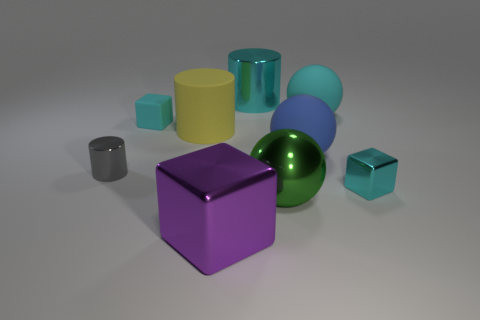What material is the big yellow object that is the same shape as the gray object?
Provide a succinct answer. Rubber. There is a cube that is behind the tiny cube that is on the right side of the big cyan shiny object; what size is it?
Your answer should be compact. Small. There is a big metallic cylinder; does it have the same color as the small shiny object to the right of the yellow rubber thing?
Keep it short and to the point. Yes. What number of cyan matte blocks are left of the green object?
Offer a terse response. 1. Is the number of gray cylinders less than the number of big brown metal cylinders?
Keep it short and to the point. No. There is a cyan object that is to the right of the purple block and on the left side of the big green object; what size is it?
Offer a terse response. Large. There is a big sphere that is behind the large yellow thing; is its color the same as the big block?
Your answer should be very brief. No. Is the number of large cylinders that are in front of the large shiny ball less than the number of small metal cubes?
Give a very brief answer. Yes. There is a gray object that is the same material as the large cyan cylinder; what shape is it?
Provide a succinct answer. Cylinder. Is the material of the big blue thing the same as the green ball?
Your answer should be very brief. No. 